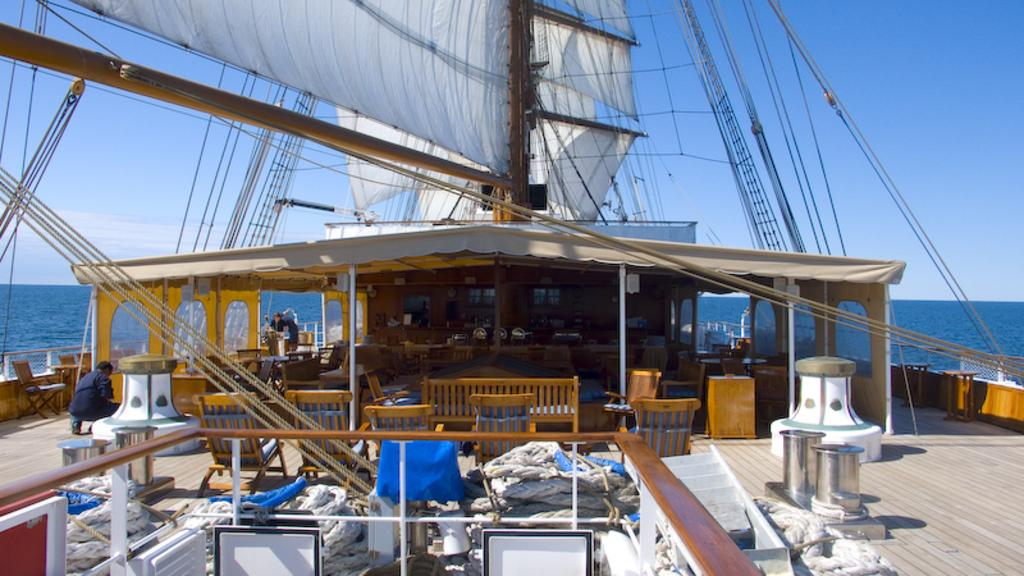What type of furniture is present in the image? There are chairs in the image. Who is sitting on the chairs in the image? A man is sitting in the image. What is the main subject in the background of the image? There is a ship in the image. How many brothers does the man have in the image? There is no information about the man's brothers in the image. What type of cable is connected to the ship in the image? There is no cable connected to the ship in the image. 